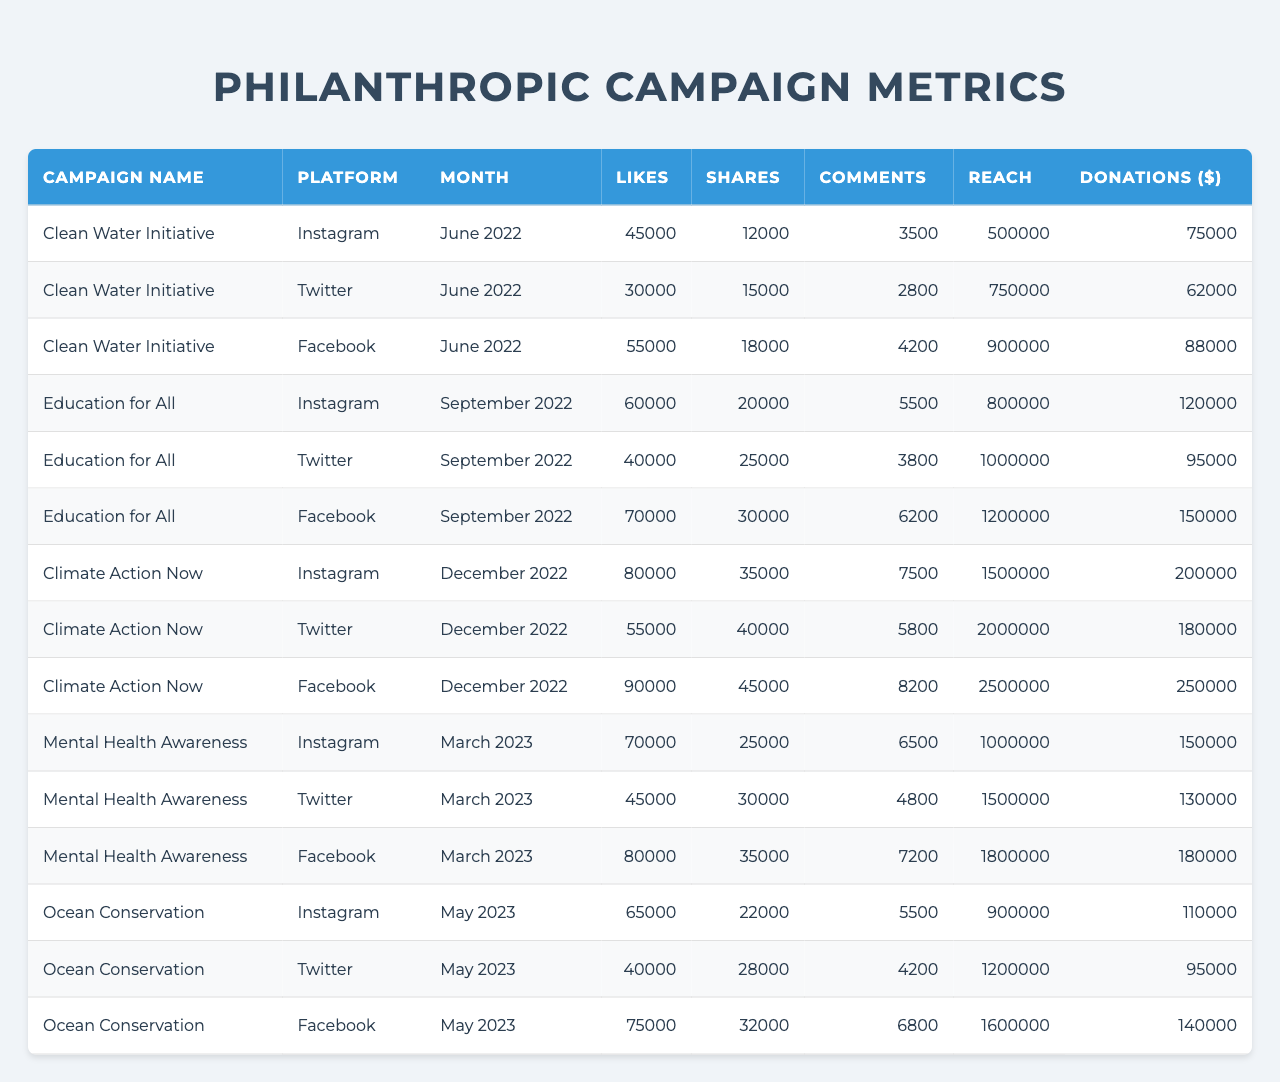What was the highest number of donations recorded in a single campaign? The highest number of donations in a single campaign is found by comparing the "Donations ($)" column. The "Climate Action Now" campaign on Facebook in December 2022 had the highest at $250,000.
Answer: $250,000 Which platform had the most total likes across all campaigns? To find the platform with the most total likes, sum the "Likes" for each platform across all campaigns: Instagram (45000 + 60000 + 80000 + 70000 + 65000 = 335000), Twitter (30000 + 40000 + 55000 + 45000 + 40000 = 210000), Facebook (55000 + 70000 + 90000 + 80000 + 75000 = 375000). Facebook has the most with 375000 likes.
Answer: Facebook Did the "Education for All" campaign generate more donations from Instagram than Twitter? Comparing the "Donations ($)" for the "Education for All" campaign: Instagram had $120,000, while Twitter had $95,000. Since $120,000 is greater than $95,000, the statement is true.
Answer: Yes How many total shares were gained from the "Ocean Conservation" campaign across all platforms? The shares from the "Ocean Conservation" campaign across all platforms are: Instagram (22000) + Twitter (28000) + Facebook (32000). Summing these gives 22000 + 28000 + 32000 = 82000 shares for the campaign.
Answer: 82000 Which campaign had the highest reach and what was that reach? The "Climate Action Now" campaign on Facebook in December 2022 had the highest reach at 2,500,000.
Answer: 2,500,000 Calculate the average number of comments for the "Mental Health Awareness" campaign. The number of comments for "Mental Health Awareness" are: Instagram (6500), Twitter (4800), and Facebook (7200). The average is calculated as (6500 + 4800 + 7200) / 3 = 6166.67, which rounds to 6167.
Answer: 6167 Was there any platform that had a lower donation amount compared to its total likes in a campaign? For the "Clean Water Initiative" on Instagram, likes were 45000, and donations were $75,000; for Twitter, likes were 30000 with donations of $62,000; and for Facebook, likes were 55000 with $88,000 donations. Each one had donations greater than likes, so the answer is no.
Answer: No What is the overall total reach from all platforms for the "Clean Water Initiative" campaign? The reach for the "Clean Water Initiative" campaign across platforms is: Instagram (500,000) + Twitter (750,000) + Facebook (900,000). The total reach is 500000 + 750000 + 900000 = 2,150,000.
Answer: 2,150,000 Which month saw the highest engagement in terms of combined likes across all campaigns? To determine the month with the highest engagement in likes, the total likes for June 2022 (45000 + 30000 + 55000 = 130000), September 2022 (60000 + 40000 + 70000 = 170000), December 2022 (80000 + 55000 + 90000 = 225000), March 2023 (70000 + 45000 + 80000 = 195000), and May 2023 (65000 + 40000 + 75000 = 180000). December 2022 had the highest likes with a total of 225000.
Answer: December 2022 How many total engagements (likes + shares + comments) occurred during the "Education for All" campaign on Facebook? The total engagements on Facebook for "Education for All" are: Likes (70000) + Shares (30000) + Comments (6200) = 70000 + 30000 + 6200 = 106200 total engagements.
Answer: 106200 